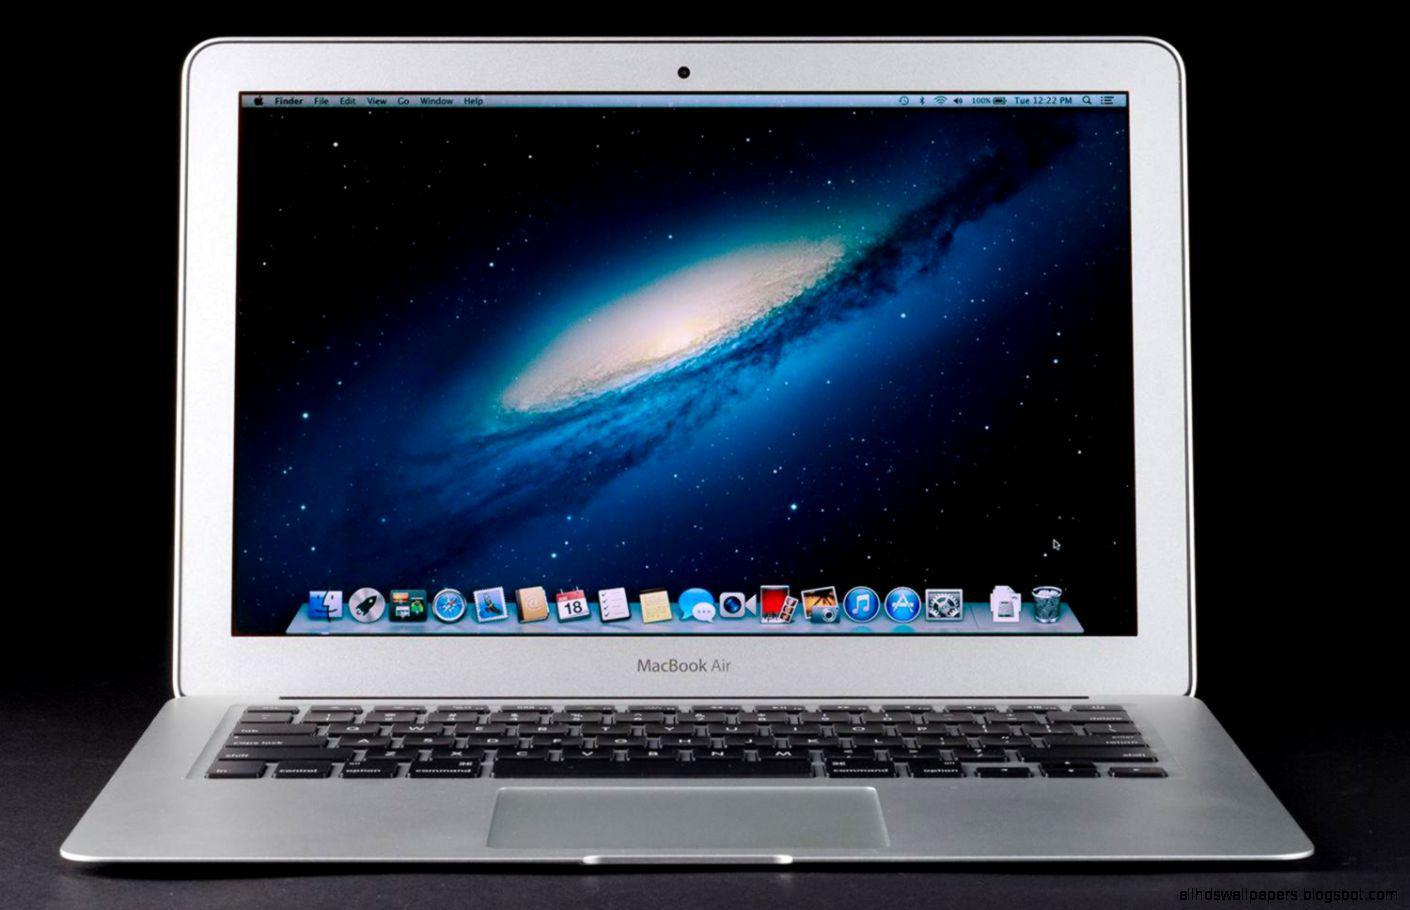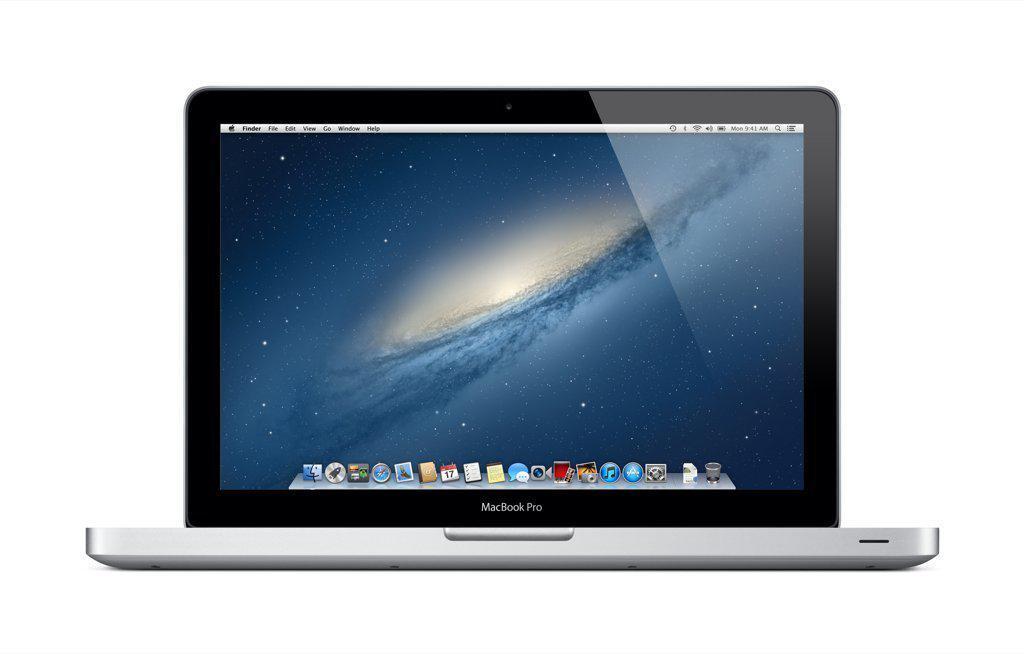The first image is the image on the left, the second image is the image on the right. Evaluate the accuracy of this statement regarding the images: "The left and right image contains the same number of fully open laptops.". Is it true? Answer yes or no. Yes. The first image is the image on the left, the second image is the image on the right. For the images displayed, is the sentence "Each image contains one device displayed so the screen is visible, and each screen has the same glowing violet and blue picture on it." factually correct? Answer yes or no. No. 